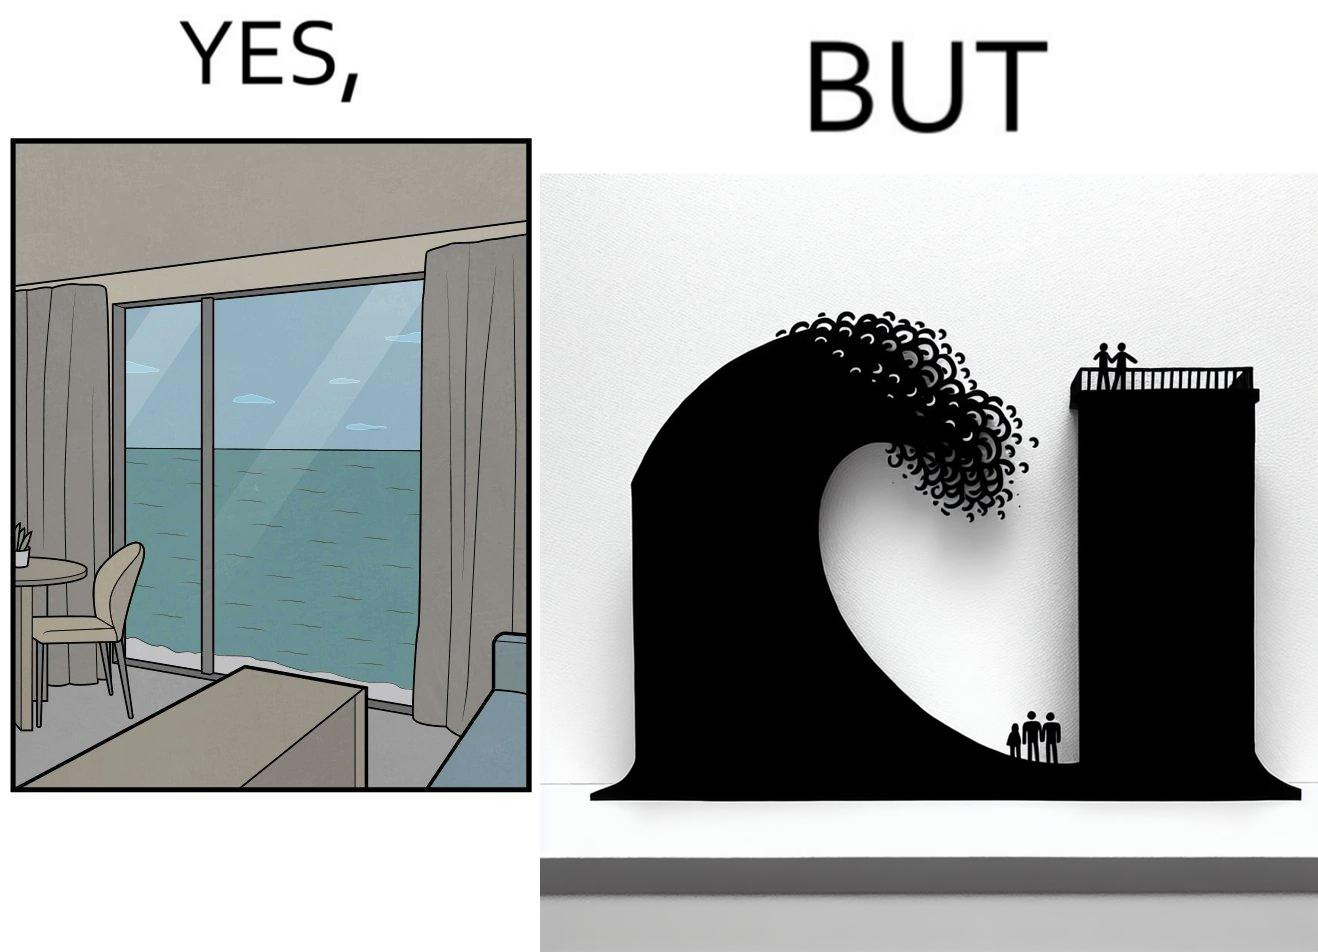Describe what you see in this image. The same sea which gives us a relaxation on a normal day can pose a danger to us sometimes like during a tsunami 